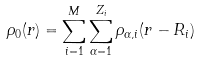Convert formula to latex. <formula><loc_0><loc_0><loc_500><loc_500>\rho _ { 0 } ( { r } ) = \sum _ { i = 1 } ^ { M } \sum _ { \alpha = 1 } ^ { Z _ { i } } \rho _ { \alpha , i } ( { r } - { R } _ { i } )</formula> 